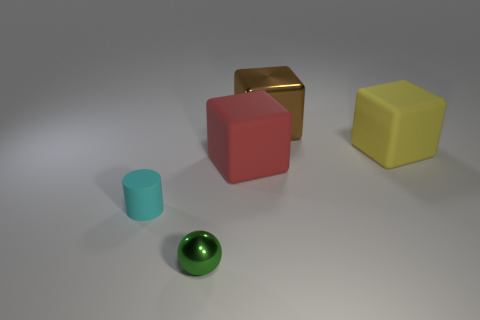Is there anything else that is the same shape as the green thing?
Your answer should be compact. No. What number of other objects are there of the same size as the cyan cylinder?
Give a very brief answer. 1. What number of large red things are in front of the shiny thing that is on the left side of the big brown thing?
Provide a succinct answer. 0. Is the number of cyan matte cylinders on the right side of the tiny cyan rubber thing less than the number of yellow balls?
Ensure brevity in your answer.  No. What shape is the large matte thing to the left of the rubber cube to the right of the block that is on the left side of the brown thing?
Provide a succinct answer. Cube. Do the red object and the yellow thing have the same shape?
Ensure brevity in your answer.  Yes. What number of other things are there of the same shape as the brown object?
Ensure brevity in your answer.  2. What color is the shiny object that is the same size as the yellow rubber object?
Give a very brief answer. Brown. Is the number of small cyan objects that are in front of the rubber cylinder the same as the number of red blocks?
Your response must be concise. No. What shape is the object that is both in front of the red rubber block and to the right of the tiny cyan matte thing?
Offer a very short reply. Sphere. 